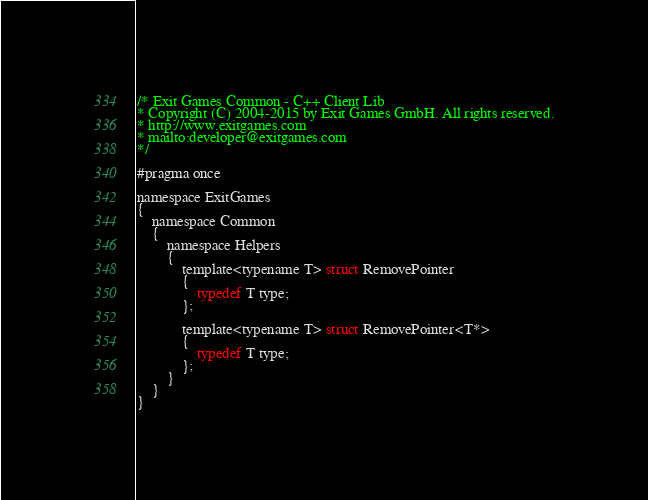<code> <loc_0><loc_0><loc_500><loc_500><_C_>/* Exit Games Common - C++ Client Lib
* Copyright (C) 2004-2015 by Exit Games GmbH. All rights reserved.
* http://www.exitgames.com
* mailto:developer@exitgames.com
*/

#pragma once

namespace ExitGames
{
	namespace Common
	{
		namespace Helpers
		{
			template<typename T> struct RemovePointer
			{
				typedef T type;
			};

			template<typename T> struct RemovePointer<T*>
			{
				typedef T type;
			};
		}
	}
}</code> 